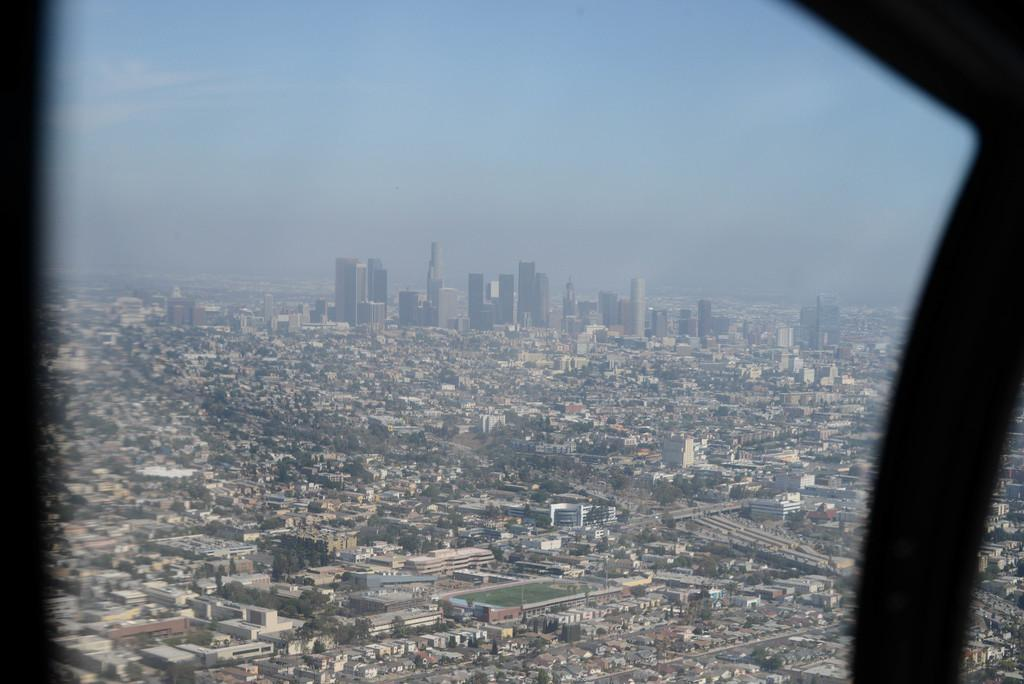What can be seen through the window in the image? Buildings are visible through the window in the image. What else is visible in the background of the image? There is sky and trees visible in the background of the image. What type of coal is being used by the doctor in the image? There is no doctor or coal present in the image. What is the quill used for in the image? There is no quill present in the image. 